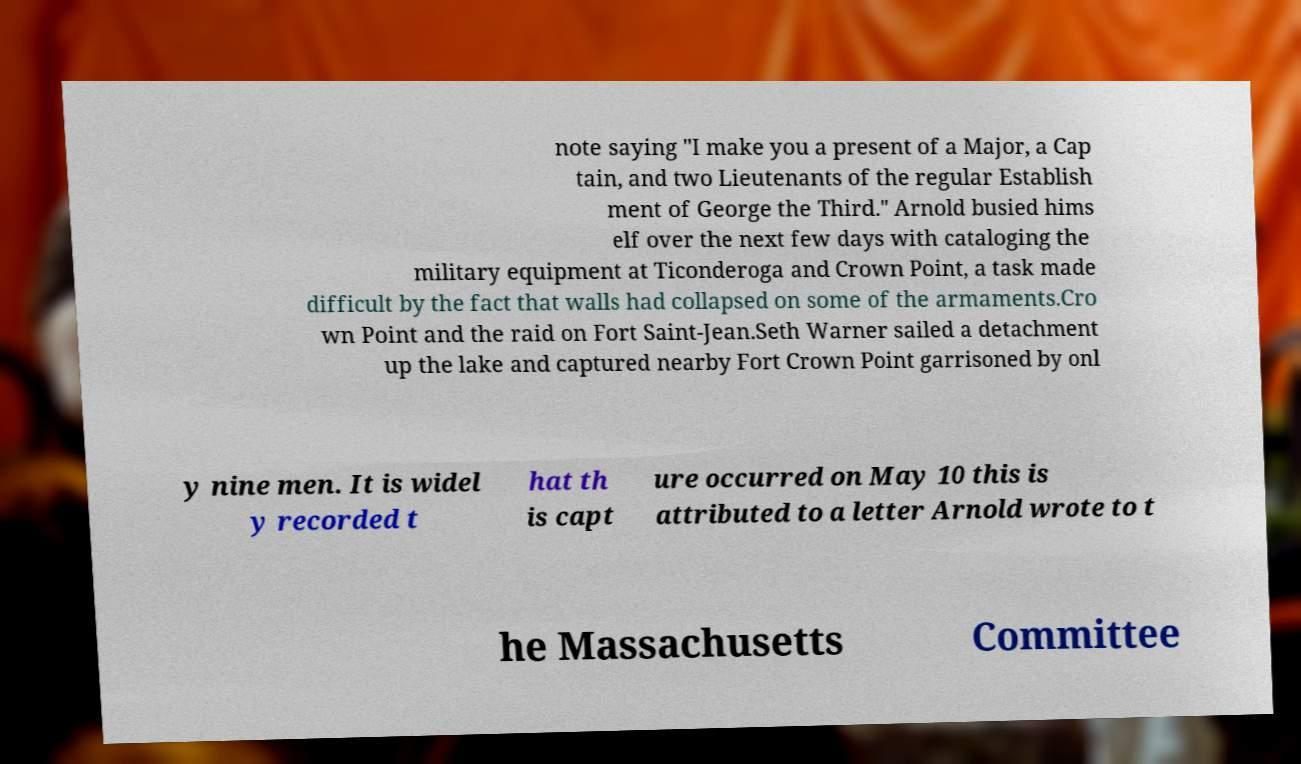Can you read and provide the text displayed in the image?This photo seems to have some interesting text. Can you extract and type it out for me? note saying "I make you a present of a Major, a Cap tain, and two Lieutenants of the regular Establish ment of George the Third." Arnold busied hims elf over the next few days with cataloging the military equipment at Ticonderoga and Crown Point, a task made difficult by the fact that walls had collapsed on some of the armaments.Cro wn Point and the raid on Fort Saint-Jean.Seth Warner sailed a detachment up the lake and captured nearby Fort Crown Point garrisoned by onl y nine men. It is widel y recorded t hat th is capt ure occurred on May 10 this is attributed to a letter Arnold wrote to t he Massachusetts Committee 